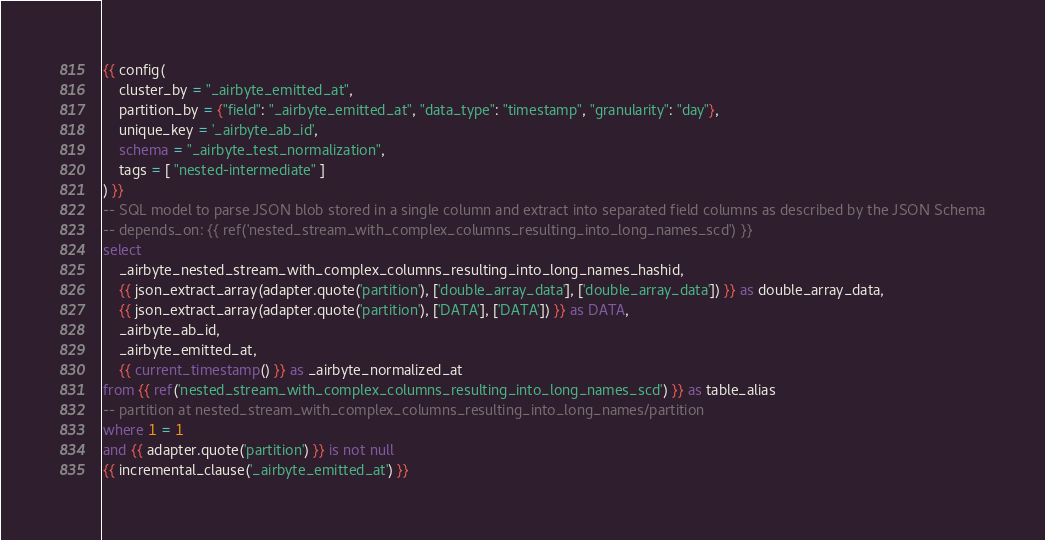<code> <loc_0><loc_0><loc_500><loc_500><_SQL_>{{ config(
    cluster_by = "_airbyte_emitted_at",
    partition_by = {"field": "_airbyte_emitted_at", "data_type": "timestamp", "granularity": "day"},
    unique_key = '_airbyte_ab_id',
    schema = "_airbyte_test_normalization",
    tags = [ "nested-intermediate" ]
) }}
-- SQL model to parse JSON blob stored in a single column and extract into separated field columns as described by the JSON Schema
-- depends_on: {{ ref('nested_stream_with_complex_columns_resulting_into_long_names_scd') }}
select
    _airbyte_nested_stream_with_complex_columns_resulting_into_long_names_hashid,
    {{ json_extract_array(adapter.quote('partition'), ['double_array_data'], ['double_array_data']) }} as double_array_data,
    {{ json_extract_array(adapter.quote('partition'), ['DATA'], ['DATA']) }} as DATA,
    _airbyte_ab_id,
    _airbyte_emitted_at,
    {{ current_timestamp() }} as _airbyte_normalized_at
from {{ ref('nested_stream_with_complex_columns_resulting_into_long_names_scd') }} as table_alias
-- partition at nested_stream_with_complex_columns_resulting_into_long_names/partition
where 1 = 1
and {{ adapter.quote('partition') }} is not null
{{ incremental_clause('_airbyte_emitted_at') }}

</code> 